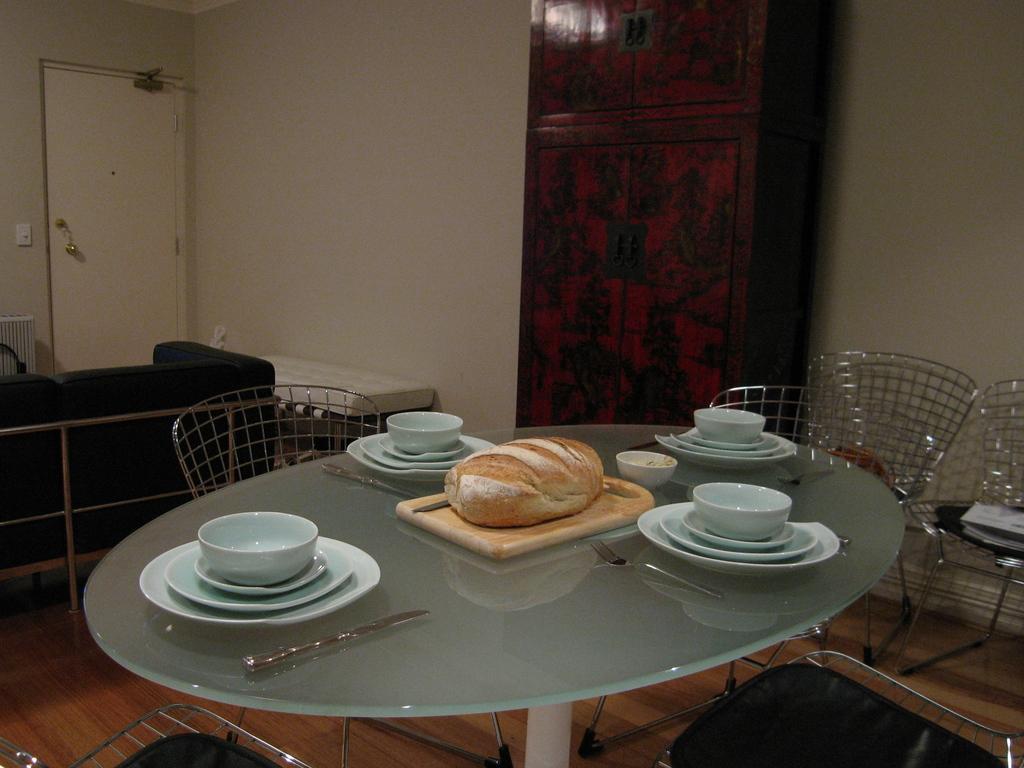Can you describe this image briefly? There is a table. And on the table there is a plate, bowls, knife, cutting table and food item. Around the table there are chairs. There is a shelf in the room. Near the wall there is a sofa and a door. 